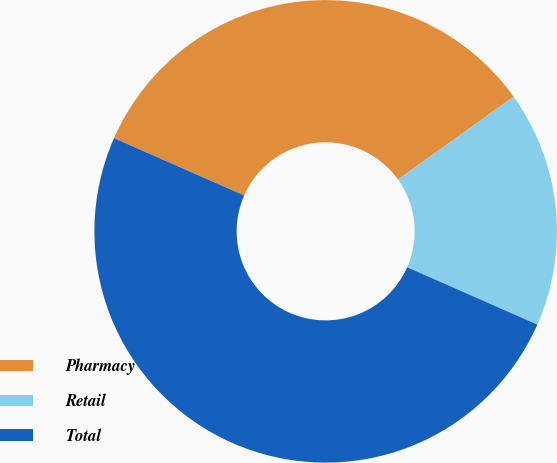<chart> <loc_0><loc_0><loc_500><loc_500><pie_chart><fcel>Pharmacy<fcel>Retail<fcel>Total<nl><fcel>33.5%<fcel>16.5%<fcel>50.0%<nl></chart> 